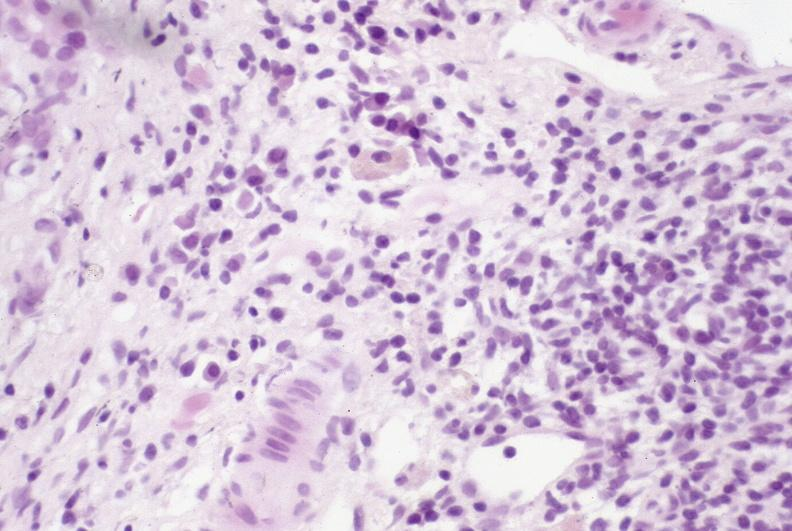s cryptosporidia present?
Answer the question using a single word or phrase. No 